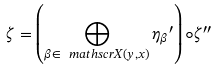Convert formula to latex. <formula><loc_0><loc_0><loc_500><loc_500>\zeta = \left ( \bigoplus _ { \beta \in \ m a t h s c r { X } ( y , x ) } { \eta _ { \beta } } ^ { \prime } \right ) \circ \zeta ^ { \prime \prime }</formula> 